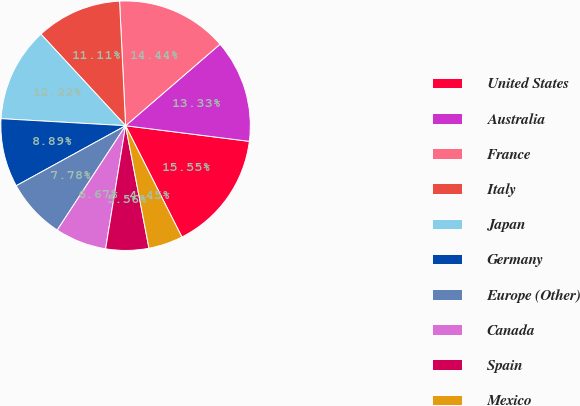<chart> <loc_0><loc_0><loc_500><loc_500><pie_chart><fcel>United States<fcel>Australia<fcel>France<fcel>Italy<fcel>Japan<fcel>Germany<fcel>Europe (Other)<fcel>Canada<fcel>Spain<fcel>Mexico<nl><fcel>15.55%<fcel>13.33%<fcel>14.44%<fcel>11.11%<fcel>12.22%<fcel>8.89%<fcel>7.78%<fcel>6.67%<fcel>5.56%<fcel>4.45%<nl></chart> 